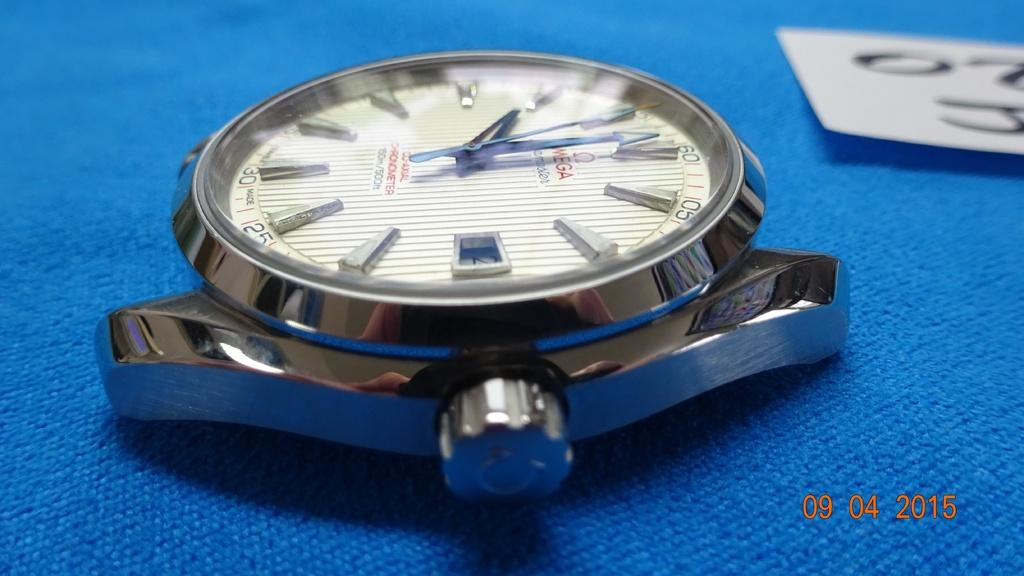<image>
Write a terse but informative summary of the picture. A watch, which has a co-axial chronometer, is displayed on a blue surface. 